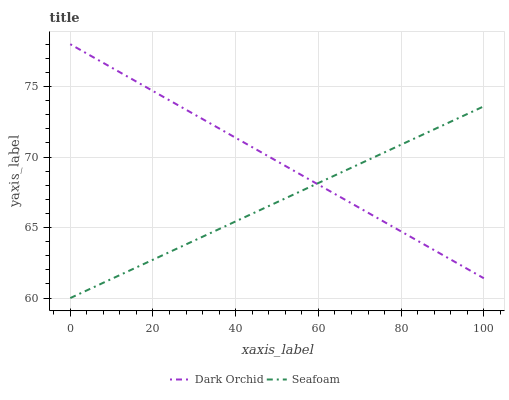Does Dark Orchid have the minimum area under the curve?
Answer yes or no. No. Is Dark Orchid the smoothest?
Answer yes or no. No. Does Dark Orchid have the lowest value?
Answer yes or no. No. 